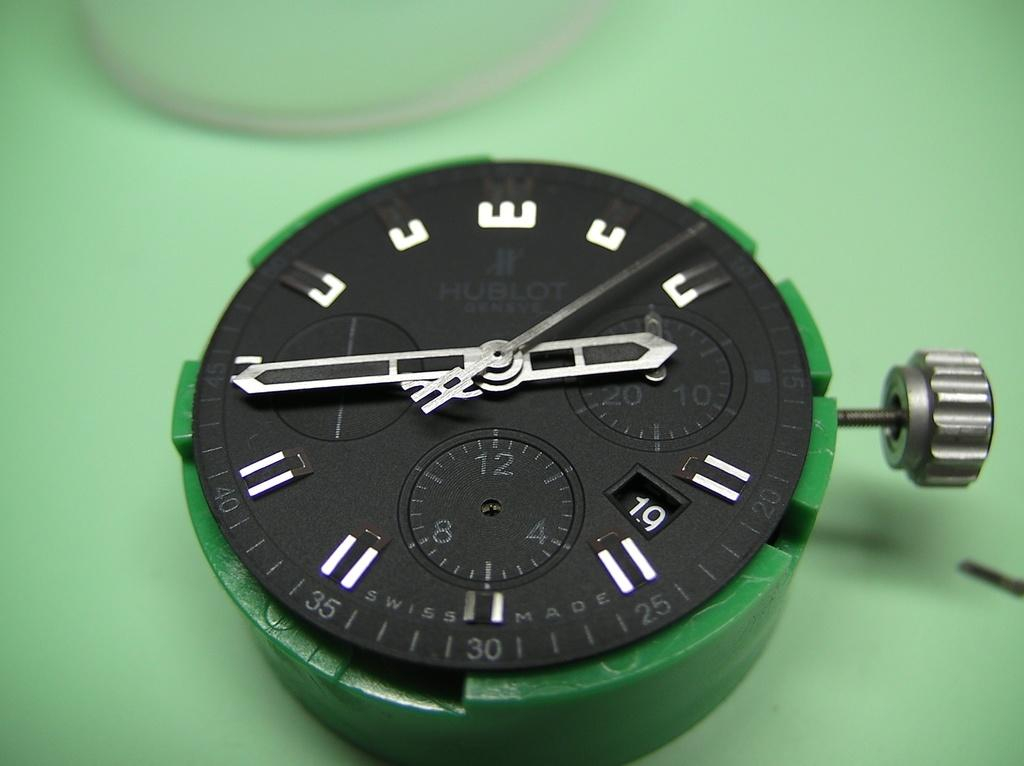<image>
Share a concise interpretation of the image provided. A watch face has the words Swiss made along the edge. 